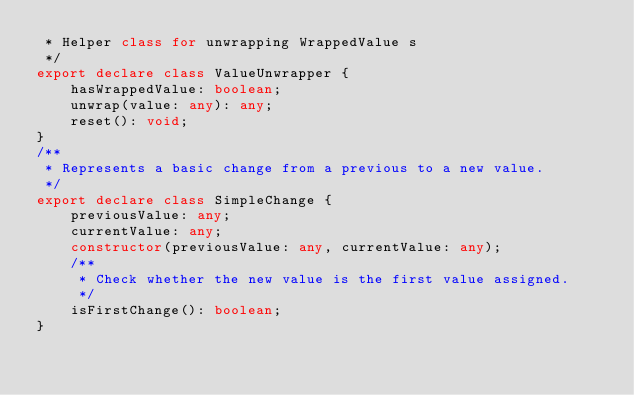<code> <loc_0><loc_0><loc_500><loc_500><_TypeScript_> * Helper class for unwrapping WrappedValue s
 */
export declare class ValueUnwrapper {
    hasWrappedValue: boolean;
    unwrap(value: any): any;
    reset(): void;
}
/**
 * Represents a basic change from a previous to a new value.
 */
export declare class SimpleChange {
    previousValue: any;
    currentValue: any;
    constructor(previousValue: any, currentValue: any);
    /**
     * Check whether the new value is the first value assigned.
     */
    isFirstChange(): boolean;
}
</code> 